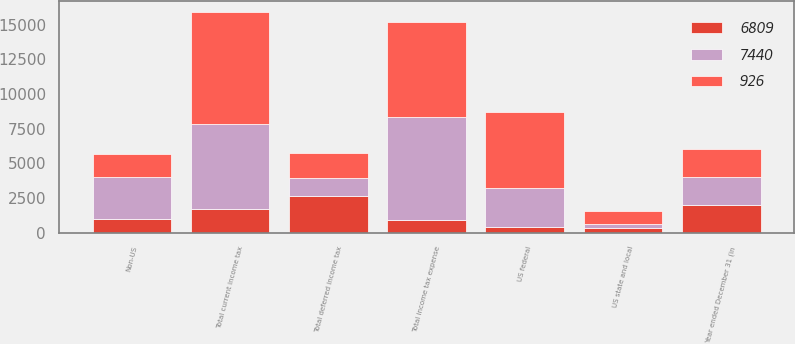Convert chart to OTSL. <chart><loc_0><loc_0><loc_500><loc_500><stacked_bar_chart><ecel><fcel>Year ended December 31 (in<fcel>US federal<fcel>Non-US<fcel>US state and local<fcel>Total current income tax<fcel>Total deferred income tax<fcel>Total income tax expense<nl><fcel>6809<fcel>2008<fcel>395<fcel>1009<fcel>307<fcel>1711<fcel>2637<fcel>926<nl><fcel>7440<fcel>2007<fcel>2805<fcel>2985<fcel>343<fcel>6133<fcel>1307<fcel>7440<nl><fcel>926<fcel>2006<fcel>5512<fcel>1656<fcel>879<fcel>8047<fcel>1810<fcel>6809<nl></chart> 